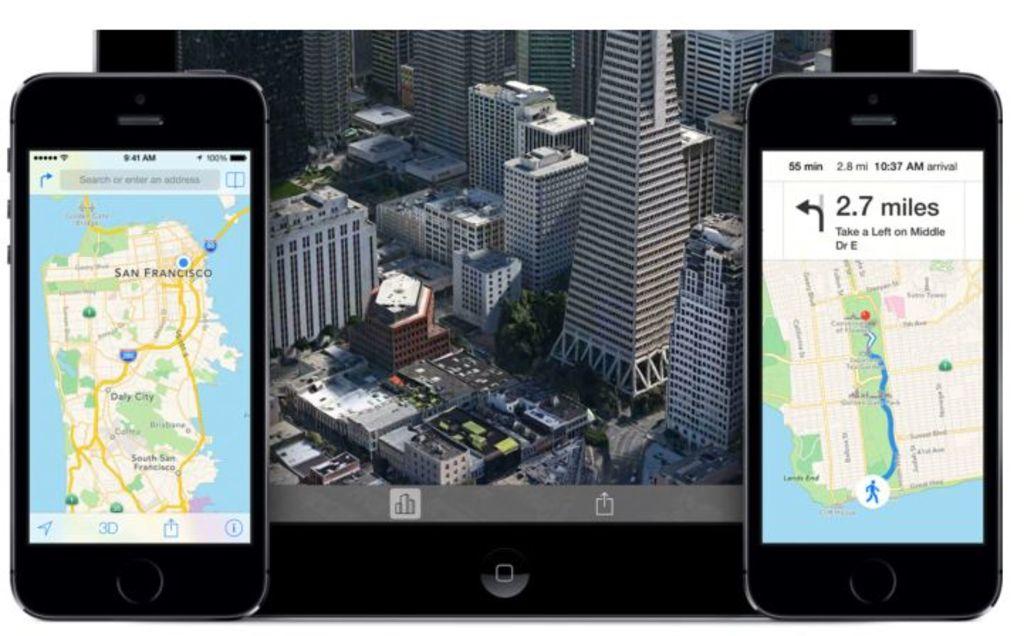How many miles does the phone mention?
Offer a very short reply. 2.7. What time is it on the left phone?
Your answer should be very brief. Unanswerable. 